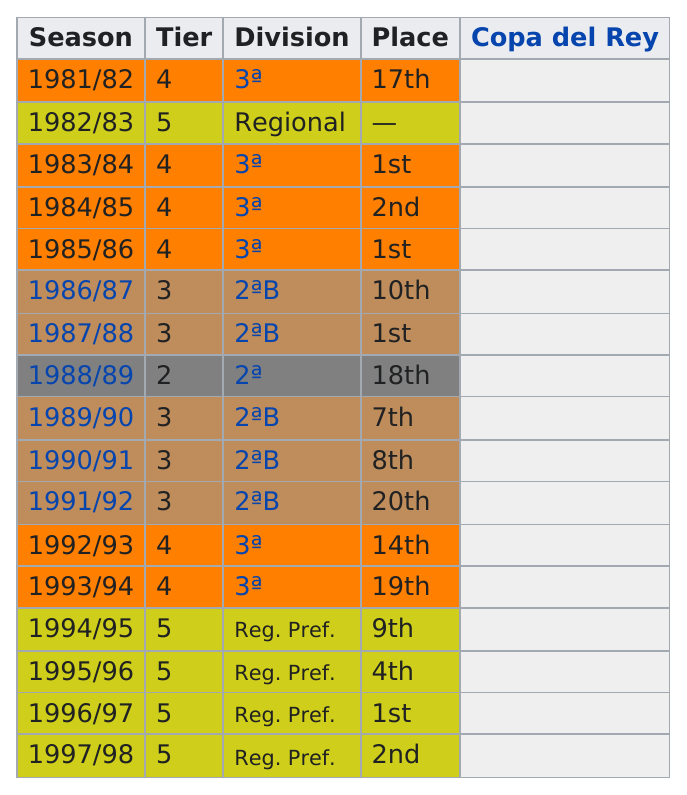Specify some key components in this picture. The team has been in Division 2 for the last year of 1991/92. There are 17 seasons depicted in this chart. In the 1991/92 season, the team experienced its worst performance record. For how many years were they in Tier 3? The answer is 5. In total, they finished first 4 times. 